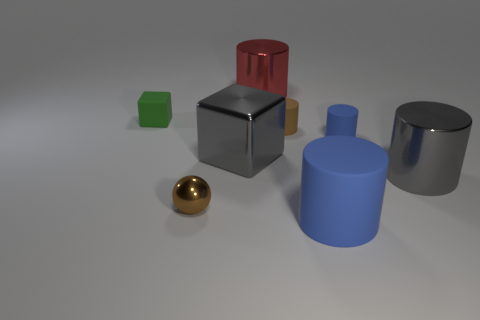Is the color of the cube that is to the left of the brown metal ball the same as the large block?
Provide a short and direct response. No. What number of brown matte cylinders are behind the block to the right of the thing that is on the left side of the tiny ball?
Your answer should be compact. 1. How many tiny things are both right of the green block and left of the large gray metallic cube?
Keep it short and to the point. 1. Is there any other thing that has the same material as the small blue cylinder?
Give a very brief answer. Yes. Does the tiny green thing have the same material as the large cube?
Give a very brief answer. No. There is a small matte object to the right of the blue rubber thing that is in front of the metal cylinder in front of the gray metallic cube; what is its shape?
Give a very brief answer. Cylinder. Are there fewer big gray things in front of the tiny brown cylinder than shiny things behind the brown metal sphere?
Offer a very short reply. Yes. There is a large gray metal object that is on the right side of the large shiny cylinder behind the small green cube; what shape is it?
Give a very brief answer. Cylinder. Are there any other things that are the same color as the tiny metallic sphere?
Offer a terse response. Yes. Do the large shiny block and the matte block have the same color?
Give a very brief answer. No. 